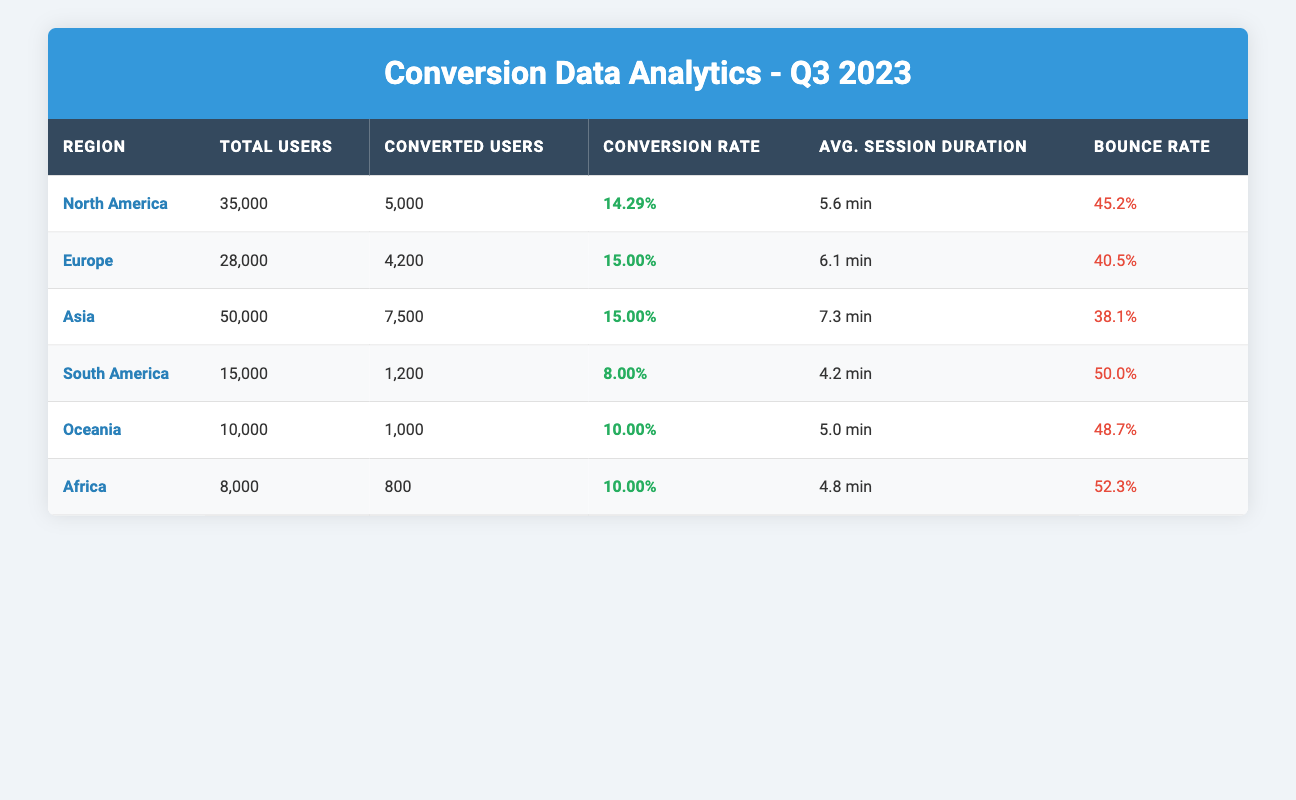What is the conversion rate for North America? The table indicates that the conversion rate for North America is explicitly shown in the "Conversion Rate" column. It states 14.29%
Answer: 14.29% Which region has the highest bounce rate? By comparing the "Bounce Rate" percentages across all regions in the table, South America has the highest bounce rate at 50.0%
Answer: 50.0% What is the total number of converted users in Europe and Oceania combined? To find the total converted users in Europe and Oceania, we add the respective values from the "Converted Users" column: Europe (4,200) + Oceania (1,000) = 5,200
Answer: 5,200 Is there any region with a conversion rate below 10%? Looking through the "Conversion Rate" column, we see that South America has a conversion rate of 8.00%, which is below 10%
Answer: Yes What is the average session duration for users in Asia compared to those in Africa? We identify the average session duration for Asia (7.3 minutes) and Africa (4.8 minutes) from the table. To compare, we see that 7.3 minutes is greater than 4.8 minutes
Answer: Asia has a longer average session duration than Africa Which region had the lowest number of total users, and what was that number? In the "Total Users" column, we compare all the values, and South America has the lowest total number of users at 15,000
Answer: 15,000 Calculate the difference in conversion rates between North America and Europe. The conversion rate for North America is 14.29% and for Europe is 15.00%. We find the difference by subtracting: 15.00% - 14.29% = 0.71%
Answer: 0.71% How many total users were there in the regions with conversion rates greater than 10%? First, from the table, we see that the regions with conversion rates greater than 10% are North America (35,000), Europe (28,000), Asia (50,000). Adding these gives: 35,000 + 28,000 + 50,000 = 113,000 total users
Answer: 113,000 Which region has the same conversion rate as Africa? By analyzing the "Conversion Rate" column, we see that Oceania has a conversion rate equal to Africa, both at 10.00%
Answer: Oceania 